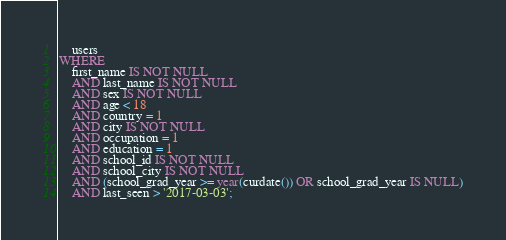<code> <loc_0><loc_0><loc_500><loc_500><_SQL_>    users
WHERE
    first_name IS NOT NULL
    AND last_name IS NOT NULL
    AND sex IS NOT NULL
    AND age < 18
    AND country = 1
    AND city IS NOT NULL
    AND occupation = 1
    AND education = 1
    AND school_id IS NOT NULL
    AND school_city IS NOT NULL
    AND (school_grad_year >= year(curdate()) OR school_grad_year IS NULL)
    AND last_seen > '2017-03-03';</code> 